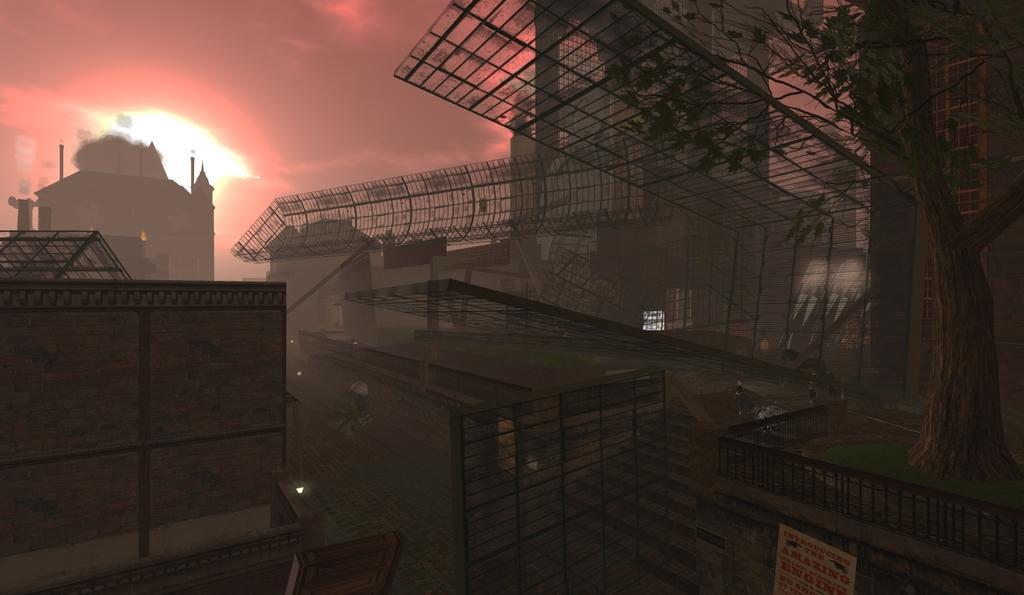In one or two sentences, can you explain what this image depicts? In this image I can see few buildings, railing. Background I can see sky in orange and gray color. 